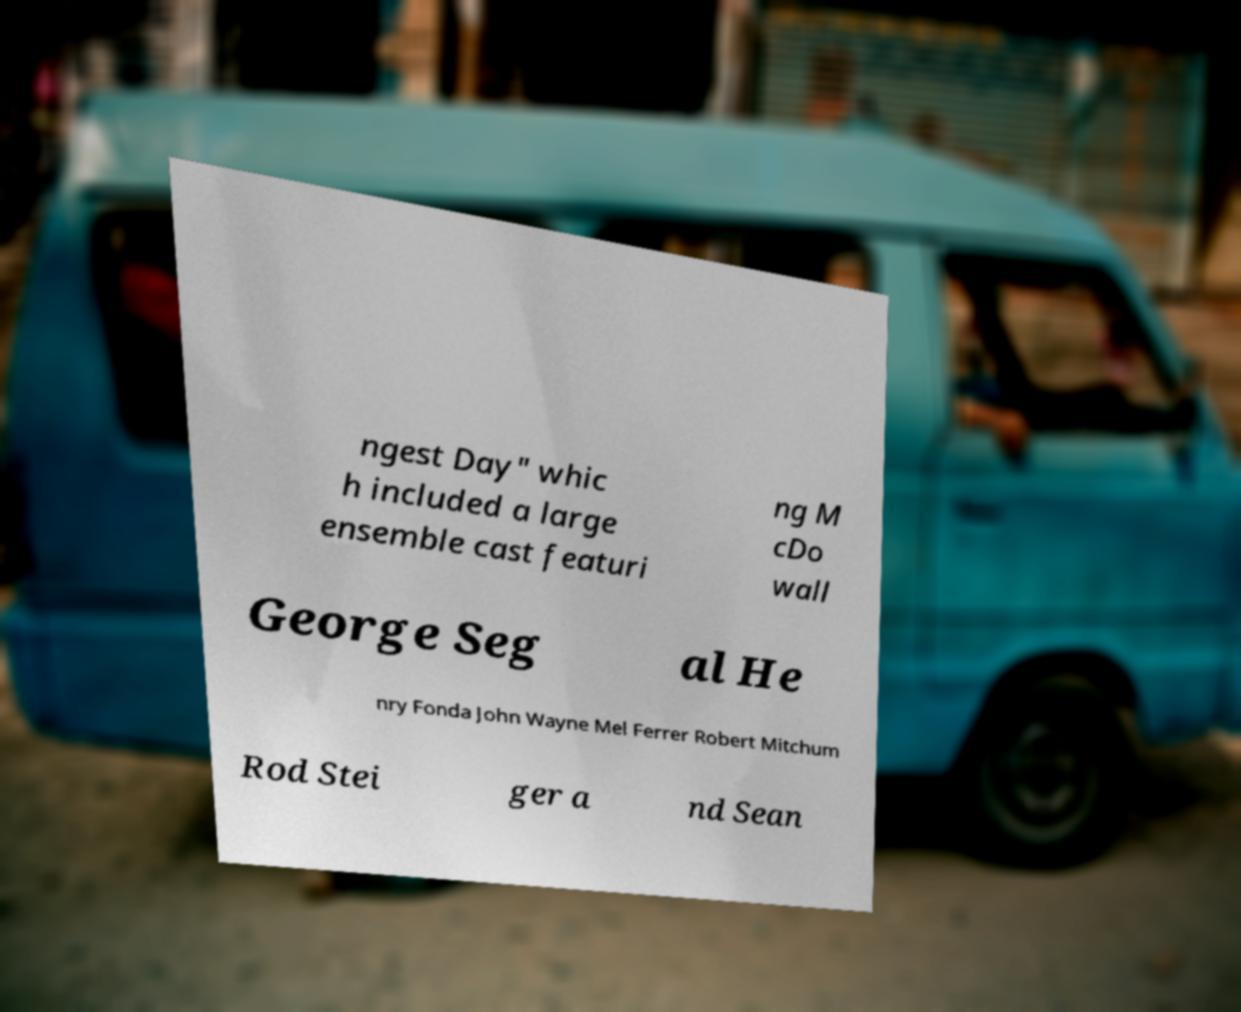Can you read and provide the text displayed in the image?This photo seems to have some interesting text. Can you extract and type it out for me? ngest Day" whic h included a large ensemble cast featuri ng M cDo wall George Seg al He nry Fonda John Wayne Mel Ferrer Robert Mitchum Rod Stei ger a nd Sean 